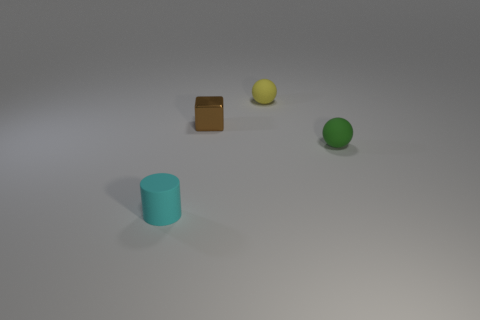Is there any other thing that has the same material as the cube?
Offer a terse response. No. Are there any small green things that have the same material as the tiny yellow ball?
Offer a very short reply. Yes. What is the material of the small ball behind the object that is right of the yellow matte sphere?
Make the answer very short. Rubber. What is the tiny object that is both on the left side of the yellow rubber sphere and behind the green rubber thing made of?
Make the answer very short. Metal. Is the number of small green rubber objects that are in front of the green matte thing the same as the number of small green matte balls?
Keep it short and to the point. No. How many other brown metal objects have the same shape as the brown thing?
Offer a very short reply. 0. There is a rubber sphere behind the small rubber ball to the right of the small matte sphere that is to the left of the green sphere; what is its size?
Make the answer very short. Small. Is the tiny ball that is behind the green ball made of the same material as the small brown thing?
Your answer should be very brief. No. Is the number of tiny cyan cylinders behind the green thing the same as the number of tiny cyan things that are on the left side of the tiny brown metal block?
Make the answer very short. No. There is another thing that is the same shape as the yellow thing; what is it made of?
Provide a succinct answer. Rubber. 